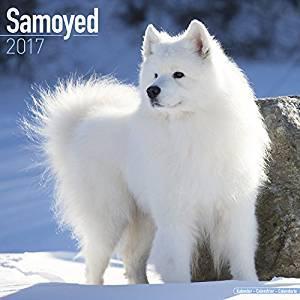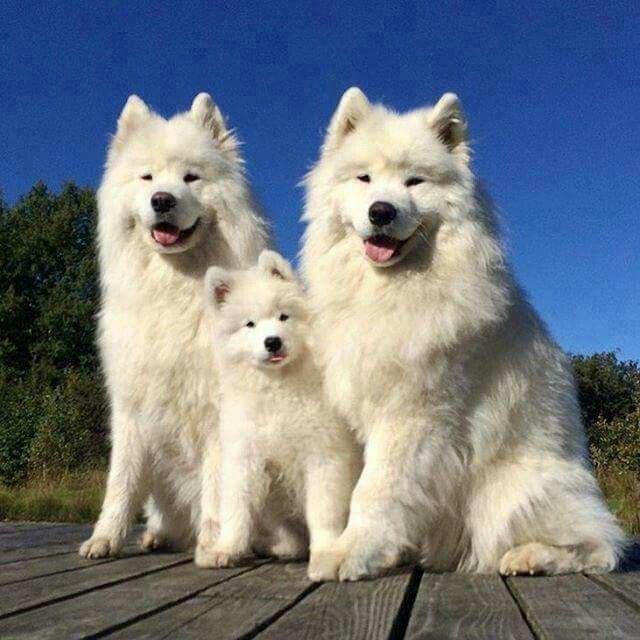The first image is the image on the left, the second image is the image on the right. For the images displayed, is the sentence "At least two dogs have have visible tongues." factually correct? Answer yes or no. Yes. 